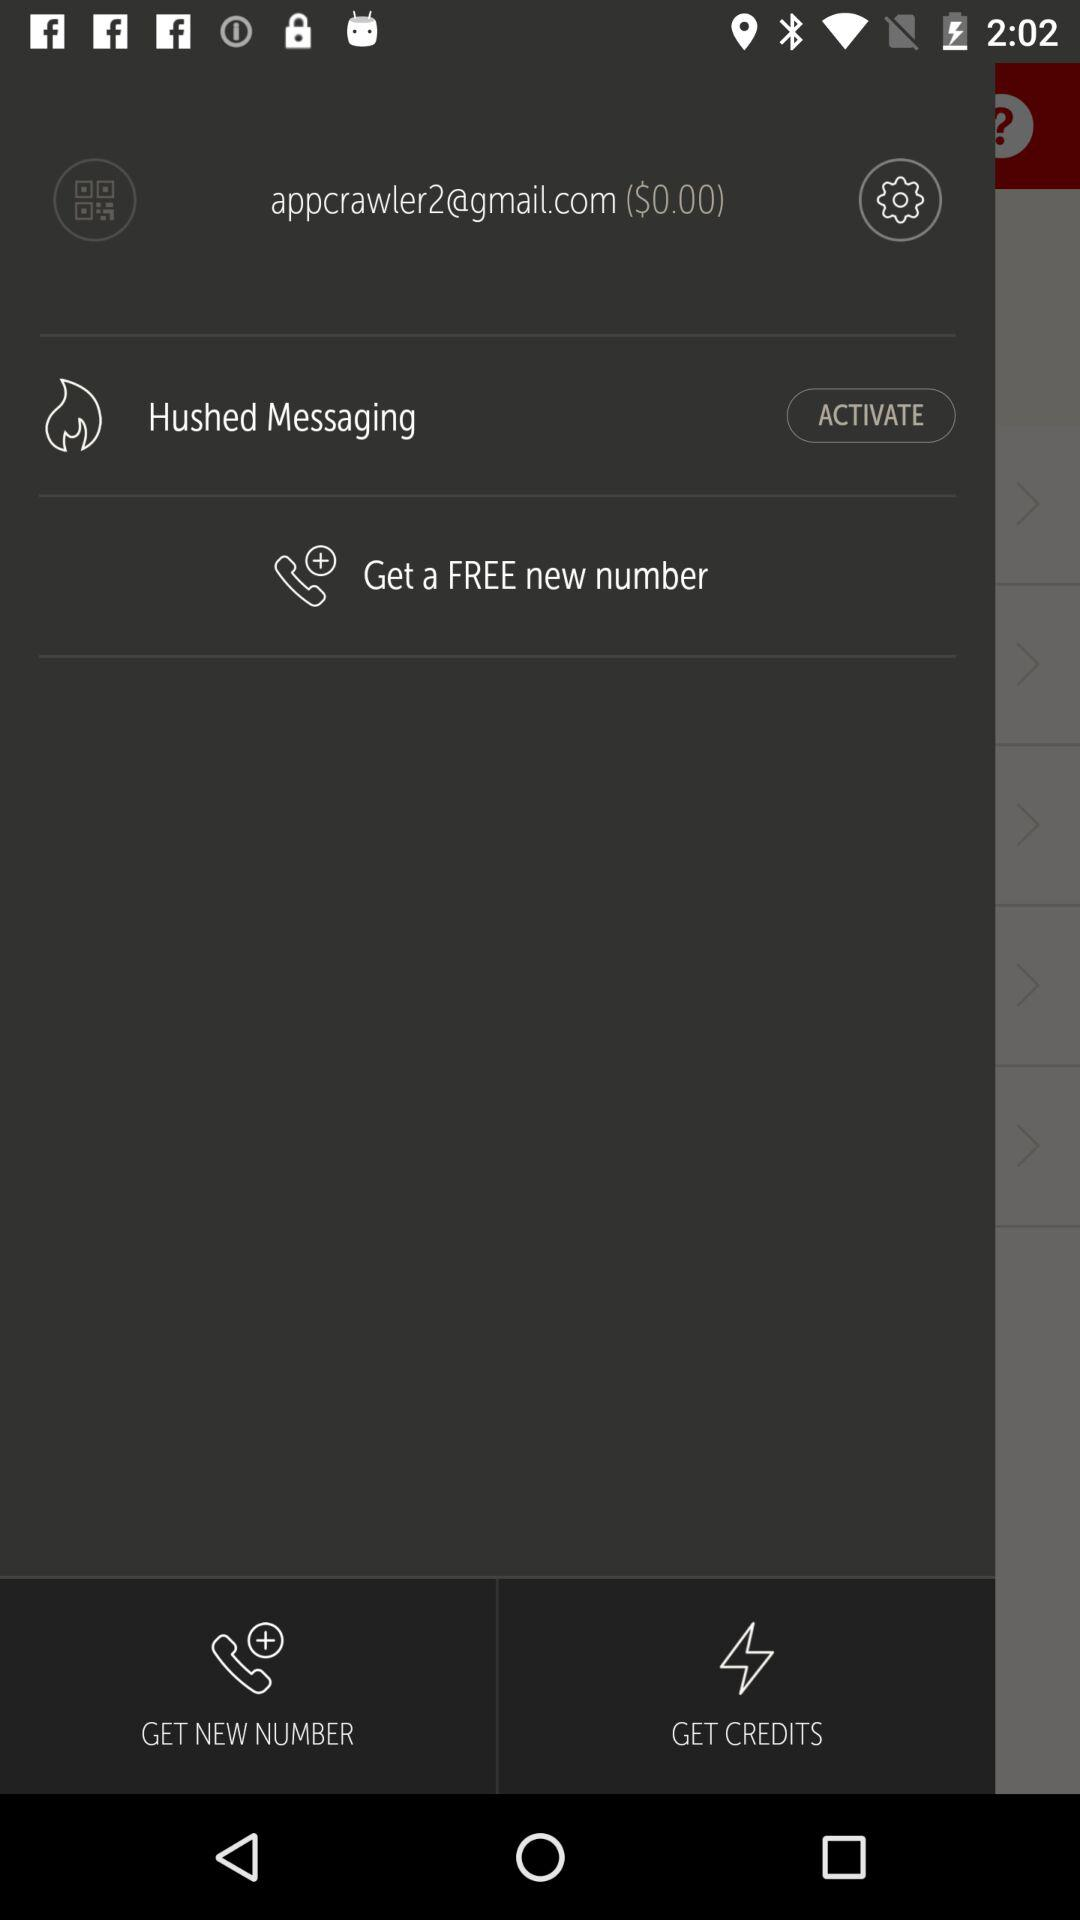What is the email address? The email address is appcrawler2@gmail.com. 